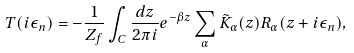Convert formula to latex. <formula><loc_0><loc_0><loc_500><loc_500>T ( i \epsilon _ { n } ) = - \frac { 1 } { Z _ { f } } \int _ { C } \frac { d z } { 2 \pi i } e ^ { - \beta z } \sum _ { \alpha } \tilde { K } _ { \alpha } ( z ) R _ { \alpha } ( z + i \epsilon _ { n } ) ,</formula> 